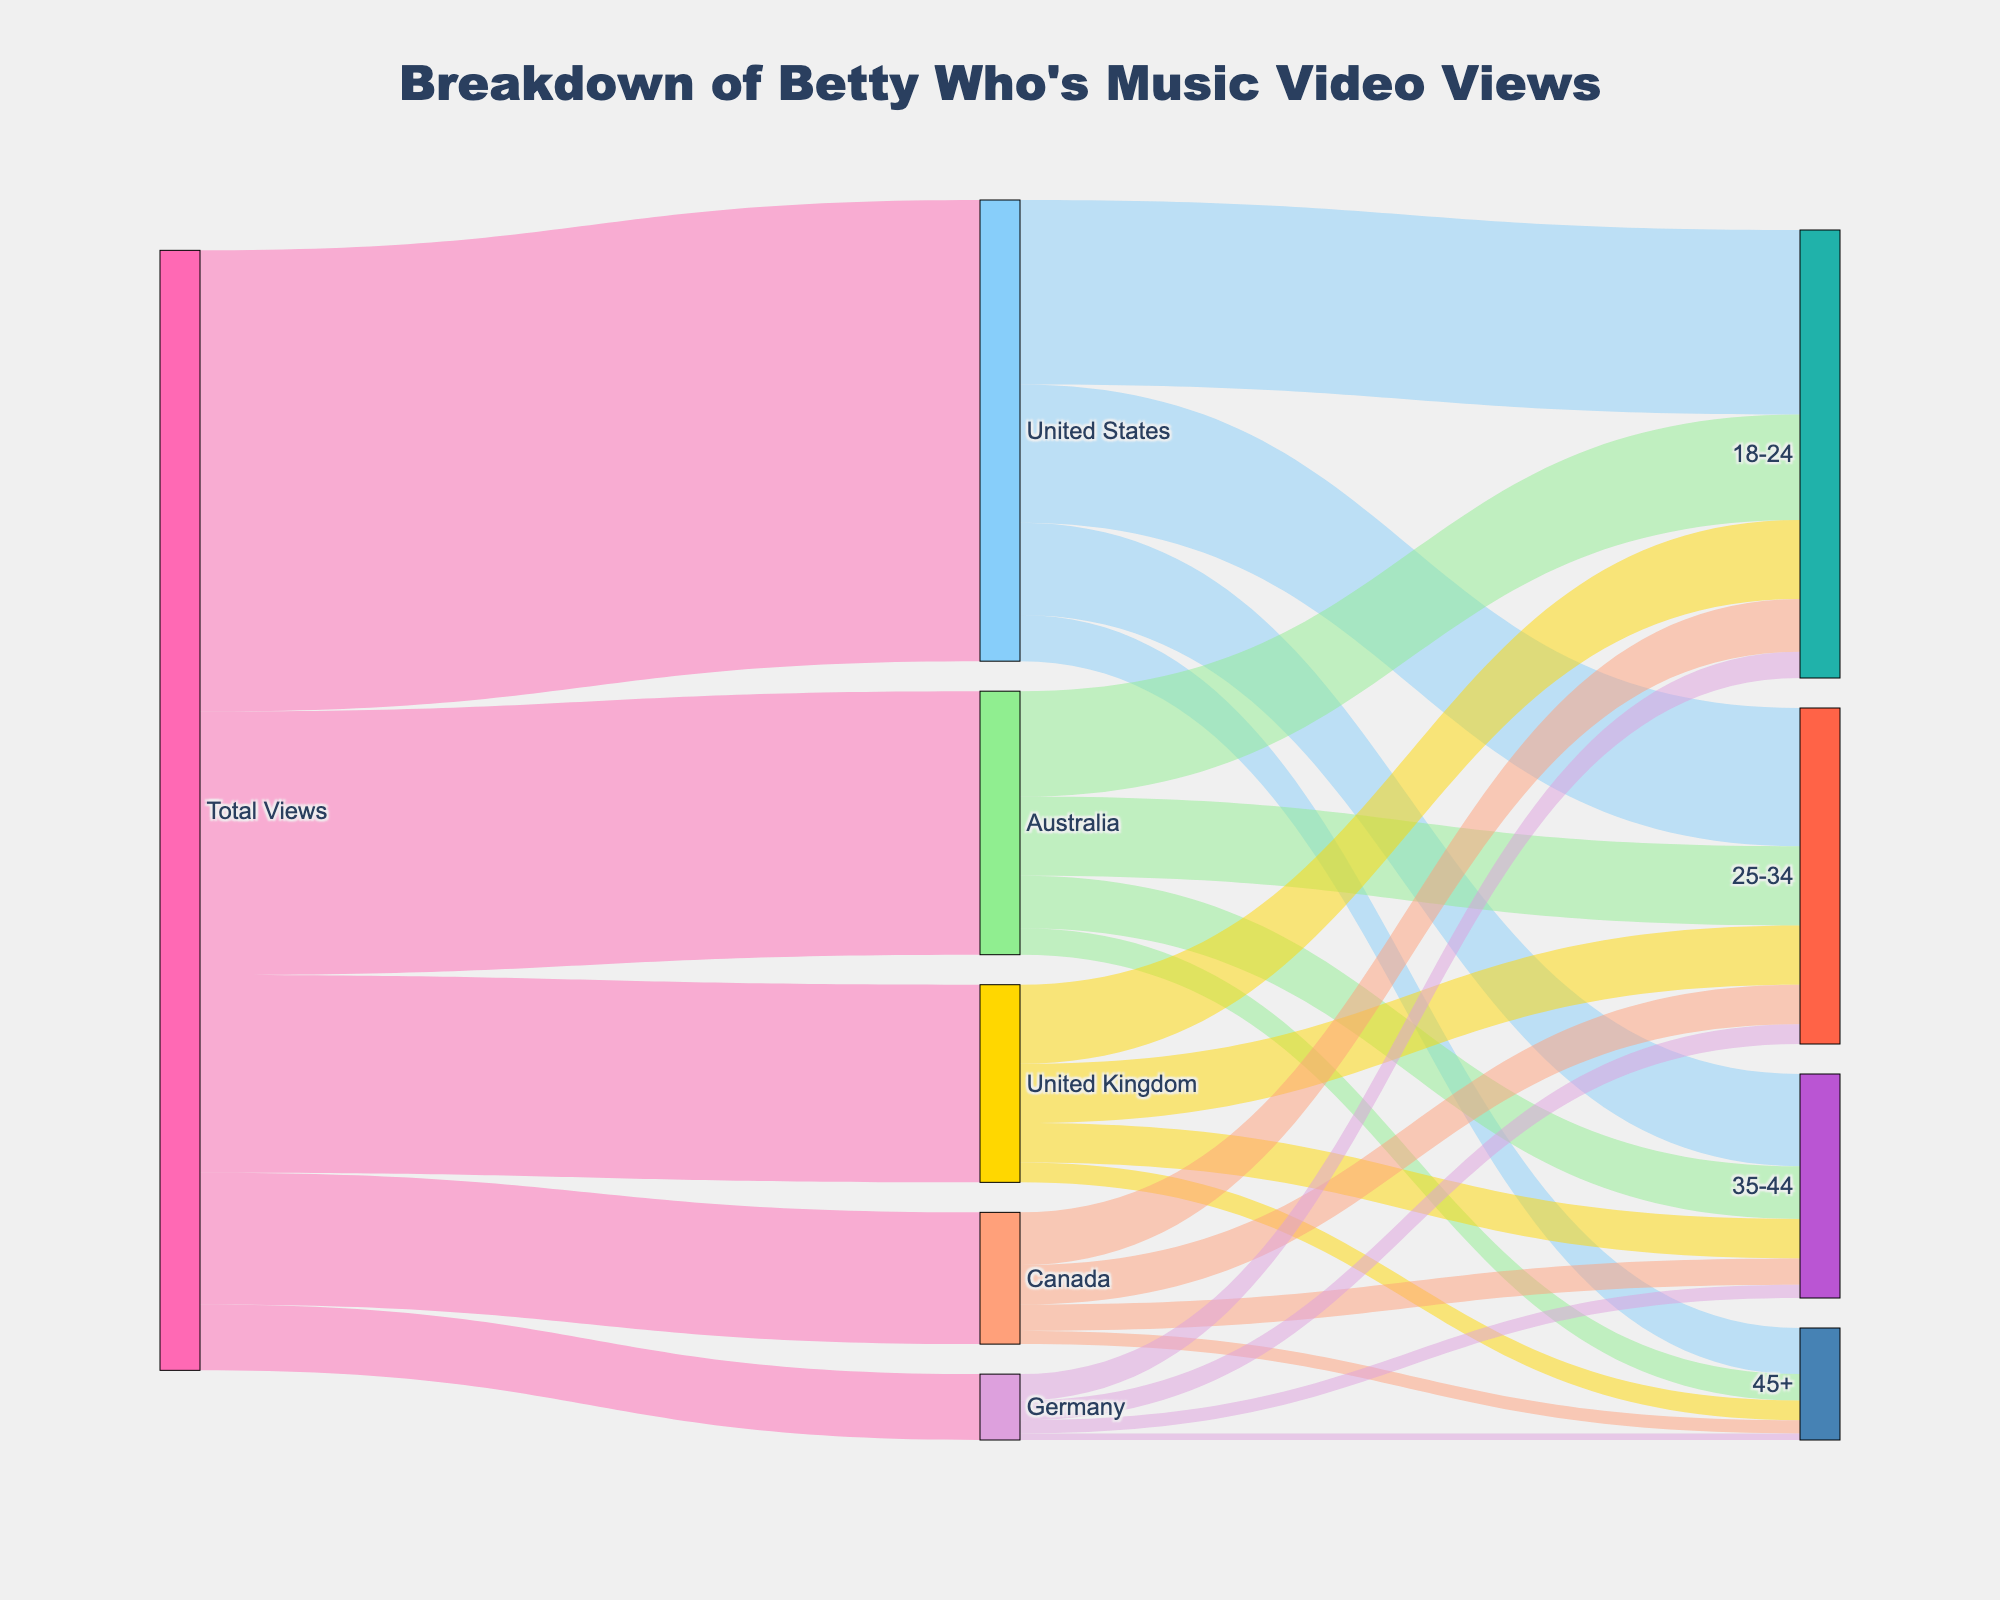What is the title of the figure? The title is displayed at the top of the Sankey Diagram, specifying the breakdown information.
Answer: Breakdown of Betty Who's Music Video Views Which country has the highest total views? By observing the flow of the largest links from 'Total Views', it is clear which country receives the most views.
Answer: United States How many total views does Germany have? Follow the flow from 'Total Views' to 'Germany', noting the value provided.
Answer: 500,000 What is the color assigned to the '18-24' demographic? Look at the node color in the Sankey Diagram for the '18-24' label.
Answer: Light Sea Green (hex #20B2AA) What percentage of the United States views comes from the 18-24 demographic? Identify the total views for the United States and then identify the amount from the 18-24 demographic. Calculate (1400000 / 3500000) * 100.
Answer: 40% Which demographic group has the smallest number of views in Canada? Observe the node links flowing out from Canada, identifying the value associated with each group, and determine which is smallest.
Answer: 45+ Compare the total views of 18-24 demographic between Australia and the United Kingdom. Look at the nodes connected to '18-24' for both countries and compare their values.
Answer: Australia has 800,000; UK has 600,000 What is the total number of views for the 25-34 demographic across all countries? Sum the views from the '25-34' nodes from all countries (1,050,000 US + 600,000 AU + 450,000 UK + 300,000 CA + 150,000 DE).
Answer: 2,550,000 What proportion of Canadian views comes from the 35-44 demographic? Identify the total views for Canada, then the views for the 35-44 demographic. Calculate (200,000 / 1,000,000) * 100.
Answer: 20% Which country has the highest number of views in the 35-44 demographic? Compare the values in the 35-44 demographic nodes for all countries to find the highest.
Answer: United States 